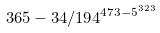<formula> <loc_0><loc_0><loc_500><loc_500>3 6 5 - 3 4 / 1 9 4 ^ { 4 7 3 - 5 ^ { 3 2 3 } }</formula> 